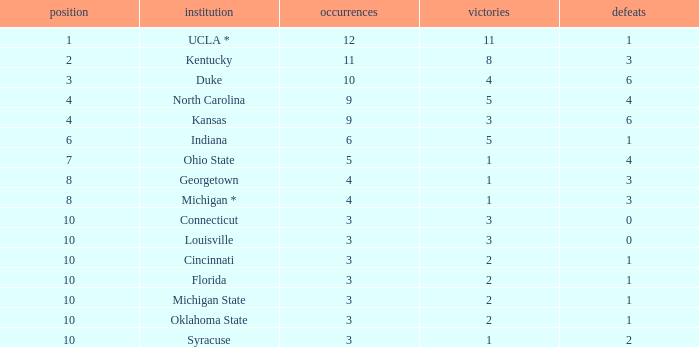Tell me the average Rank for lossess less than 6 and wins less than 11 for michigan state 10.0. 